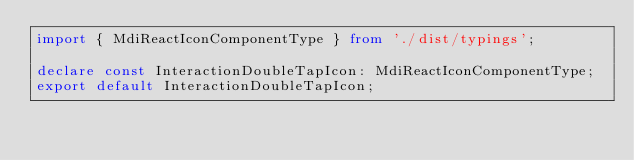Convert code to text. <code><loc_0><loc_0><loc_500><loc_500><_TypeScript_>import { MdiReactIconComponentType } from './dist/typings';

declare const InteractionDoubleTapIcon: MdiReactIconComponentType;
export default InteractionDoubleTapIcon;
</code> 